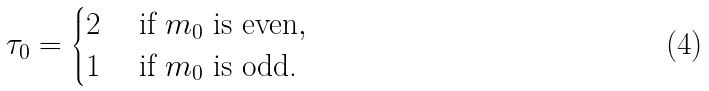Convert formula to latex. <formula><loc_0><loc_0><loc_500><loc_500>\tau _ { 0 } = \begin{cases} 2 & \text { if } m _ { 0 } \text { is even} , \\ 1 & \text { if } m _ { 0 } \text { is odd.} \end{cases}</formula> 